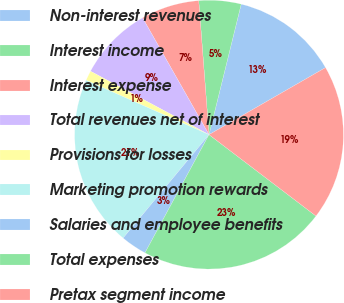<chart> <loc_0><loc_0><loc_500><loc_500><pie_chart><fcel>Non-interest revenues<fcel>Interest income<fcel>Interest expense<fcel>Total revenues net of interest<fcel>Provisions for losses<fcel>Marketing promotion rewards<fcel>Salaries and employee benefits<fcel>Total expenses<fcel>Pretax segment income<nl><fcel>12.84%<fcel>5.07%<fcel>7.01%<fcel>8.95%<fcel>1.19%<fcel>20.6%<fcel>3.13%<fcel>22.55%<fcel>18.66%<nl></chart> 